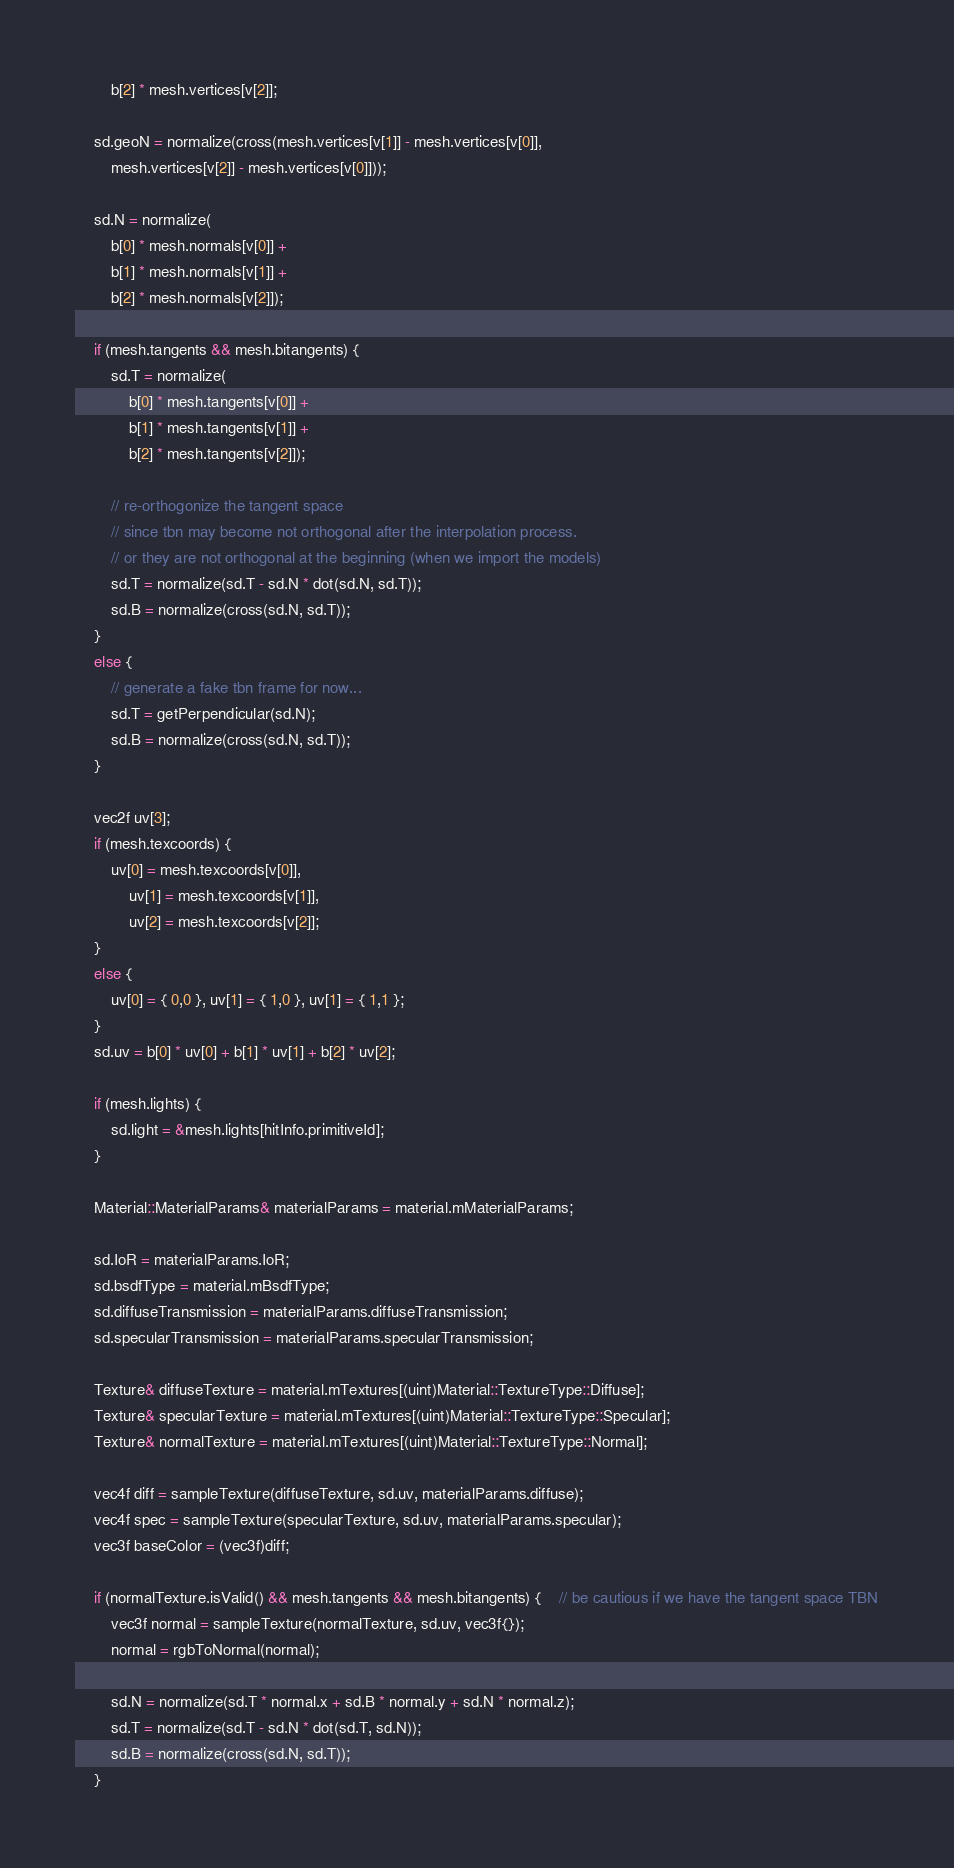<code> <loc_0><loc_0><loc_500><loc_500><_Cuda_>		b[2] * mesh.vertices[v[2]];

	sd.geoN = normalize(cross(mesh.vertices[v[1]] - mesh.vertices[v[0]],
		mesh.vertices[v[2]] - mesh.vertices[v[0]]));

	sd.N = normalize(
		b[0] * mesh.normals[v[0]] +
		b[1] * mesh.normals[v[1]] +
		b[2] * mesh.normals[v[2]]);

	if (mesh.tangents && mesh.bitangents) {
		sd.T = normalize(
			b[0] * mesh.tangents[v[0]] +
			b[1] * mesh.tangents[v[1]] +
			b[2] * mesh.tangents[v[2]]);
		
		// re-orthogonize the tangent space 
		// since tbn may become not orthogonal after the interpolation process.
		// or they are not orthogonal at the beginning (when we import the models)
		sd.T = normalize(sd.T - sd.N * dot(sd.N, sd.T));
		sd.B = normalize(cross(sd.N, sd.T));
	}
	else {
		// generate a fake tbn frame for now...
		sd.T = getPerpendicular(sd.N);
		sd.B = normalize(cross(sd.N, sd.T));
	}

	vec2f uv[3];
	if (mesh.texcoords) {
		uv[0] = mesh.texcoords[v[0]],
			uv[1] = mesh.texcoords[v[1]],
			uv[2] = mesh.texcoords[v[2]];
	}
	else {
		uv[0] = { 0,0 }, uv[1] = { 1,0 }, uv[1] = { 1,1 };
	}
	sd.uv = b[0] * uv[0] + b[1] * uv[1] + b[2] * uv[2];

	if (mesh.lights) {
		sd.light = &mesh.lights[hitInfo.primitiveId];
	}

	Material::MaterialParams& materialParams = material.mMaterialParams;
	
	sd.IoR = materialParams.IoR;
	sd.bsdfType = material.mBsdfType;
	sd.diffuseTransmission = materialParams.diffuseTransmission;
	sd.specularTransmission = materialParams.specularTransmission;

	Texture& diffuseTexture = material.mTextures[(uint)Material::TextureType::Diffuse];
	Texture& specularTexture = material.mTextures[(uint)Material::TextureType::Specular];
	Texture& normalTexture = material.mTextures[(uint)Material::TextureType::Normal];

	vec4f diff = sampleTexture(diffuseTexture, sd.uv, materialParams.diffuse);
	vec4f spec = sampleTexture(specularTexture, sd.uv, materialParams.specular);
	vec3f baseColor = (vec3f)diff;

	if (normalTexture.isValid() && mesh.tangents && mesh.bitangents) {	// be cautious if we have the tangent space TBN
		vec3f normal = sampleTexture(normalTexture, sd.uv, vec3f{});
		normal = rgbToNormal(normal);

		sd.N = normalize(sd.T * normal.x + sd.B * normal.y + sd.N * normal.z);
		sd.T = normalize(sd.T - sd.N * dot(sd.T, sd.N));
		sd.B = normalize(cross(sd.N, sd.T));
	}
</code> 